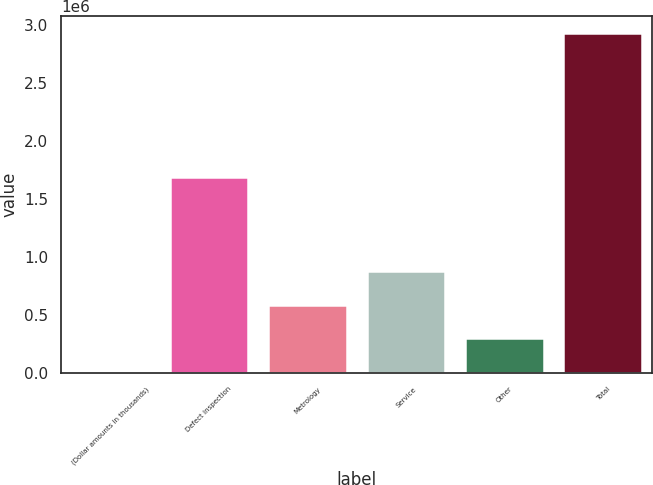Convert chart. <chart><loc_0><loc_0><loc_500><loc_500><bar_chart><fcel>(Dollar amounts in thousands)<fcel>Defect inspection<fcel>Metrology<fcel>Service<fcel>Other<fcel>Total<nl><fcel>2014<fcel>1.68511e+06<fcel>587493<fcel>880232<fcel>294753<fcel>2.92941e+06<nl></chart> 